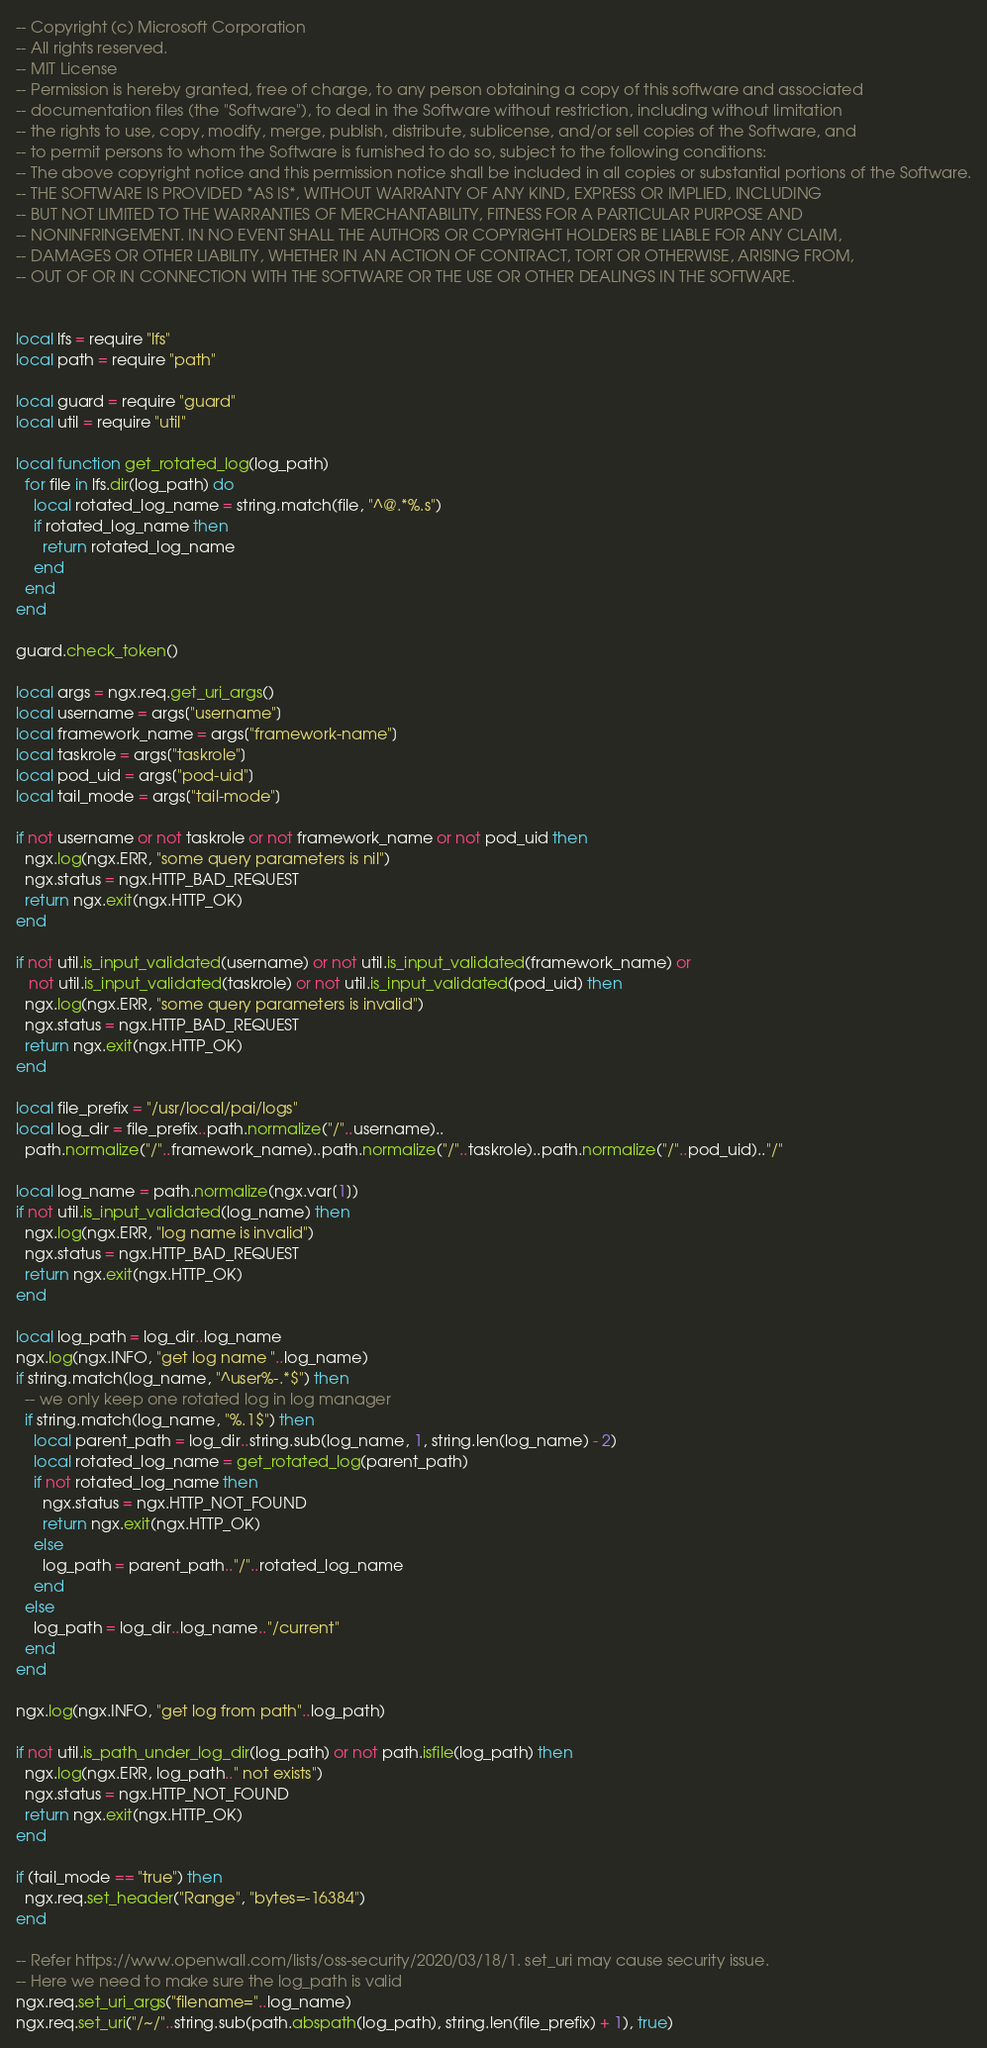<code> <loc_0><loc_0><loc_500><loc_500><_Lua_>-- Copyright (c) Microsoft Corporation
-- All rights reserved.
-- MIT License
-- Permission is hereby granted, free of charge, to any person obtaining a copy of this software and associated
-- documentation files (the "Software"), to deal in the Software without restriction, including without limitation
-- the rights to use, copy, modify, merge, publish, distribute, sublicense, and/or sell copies of the Software, and
-- to permit persons to whom the Software is furnished to do so, subject to the following conditions:
-- The above copyright notice and this permission notice shall be included in all copies or substantial portions of the Software.
-- THE SOFTWARE IS PROVIDED *AS IS*, WITHOUT WARRANTY OF ANY KIND, EXPRESS OR IMPLIED, INCLUDING
-- BUT NOT LIMITED TO THE WARRANTIES OF MERCHANTABILITY, FITNESS FOR A PARTICULAR PURPOSE AND
-- NONINFRINGEMENT. IN NO EVENT SHALL THE AUTHORS OR COPYRIGHT HOLDERS BE LIABLE FOR ANY CLAIM,
-- DAMAGES OR OTHER LIABILITY, WHETHER IN AN ACTION OF CONTRACT, TORT OR OTHERWISE, ARISING FROM,
-- OUT OF OR IN CONNECTION WITH THE SOFTWARE OR THE USE OR OTHER DEALINGS IN THE SOFTWARE.


local lfs = require "lfs"
local path = require "path"

local guard = require "guard"
local util = require "util"

local function get_rotated_log(log_path)
  for file in lfs.dir(log_path) do
    local rotated_log_name = string.match(file, "^@.*%.s")
    if rotated_log_name then
      return rotated_log_name
    end
  end
end

guard.check_token()

local args = ngx.req.get_uri_args()
local username = args["username"]
local framework_name = args["framework-name"]
local taskrole = args["taskrole"]
local pod_uid = args["pod-uid"]
local tail_mode = args["tail-mode"]

if not username or not taskrole or not framework_name or not pod_uid then
  ngx.log(ngx.ERR, "some query parameters is nil")
  ngx.status = ngx.HTTP_BAD_REQUEST
  return ngx.exit(ngx.HTTP_OK)
end

if not util.is_input_validated(username) or not util.is_input_validated(framework_name) or
   not util.is_input_validated(taskrole) or not util.is_input_validated(pod_uid) then
  ngx.log(ngx.ERR, "some query parameters is invalid")
  ngx.status = ngx.HTTP_BAD_REQUEST
  return ngx.exit(ngx.HTTP_OK)
end

local file_prefix = "/usr/local/pai/logs"
local log_dir = file_prefix..path.normalize("/"..username)..
  path.normalize("/"..framework_name)..path.normalize("/"..taskrole)..path.normalize("/"..pod_uid).."/"

local log_name = path.normalize(ngx.var[1])
if not util.is_input_validated(log_name) then
  ngx.log(ngx.ERR, "log name is invalid")
  ngx.status = ngx.HTTP_BAD_REQUEST
  return ngx.exit(ngx.HTTP_OK)
end

local log_path = log_dir..log_name
ngx.log(ngx.INFO, "get log name "..log_name)
if string.match(log_name, "^user%-.*$") then
  -- we only keep one rotated log in log manager
  if string.match(log_name, "%.1$") then
    local parent_path = log_dir..string.sub(log_name, 1, string.len(log_name) - 2)
    local rotated_log_name = get_rotated_log(parent_path)
    if not rotated_log_name then
      ngx.status = ngx.HTTP_NOT_FOUND
      return ngx.exit(ngx.HTTP_OK)
    else
      log_path = parent_path.."/"..rotated_log_name
    end
  else
    log_path = log_dir..log_name.."/current"
  end
end

ngx.log(ngx.INFO, "get log from path"..log_path)

if not util.is_path_under_log_dir(log_path) or not path.isfile(log_path) then
  ngx.log(ngx.ERR, log_path.." not exists")
  ngx.status = ngx.HTTP_NOT_FOUND
  return ngx.exit(ngx.HTTP_OK)
end

if (tail_mode == "true") then
  ngx.req.set_header("Range", "bytes=-16384")
end

-- Refer https://www.openwall.com/lists/oss-security/2020/03/18/1. set_uri may cause security issue.
-- Here we need to make sure the log_path is valid
ngx.req.set_uri_args("filename="..log_name)
ngx.req.set_uri("/~/"..string.sub(path.abspath(log_path), string.len(file_prefix) + 1), true)

</code> 